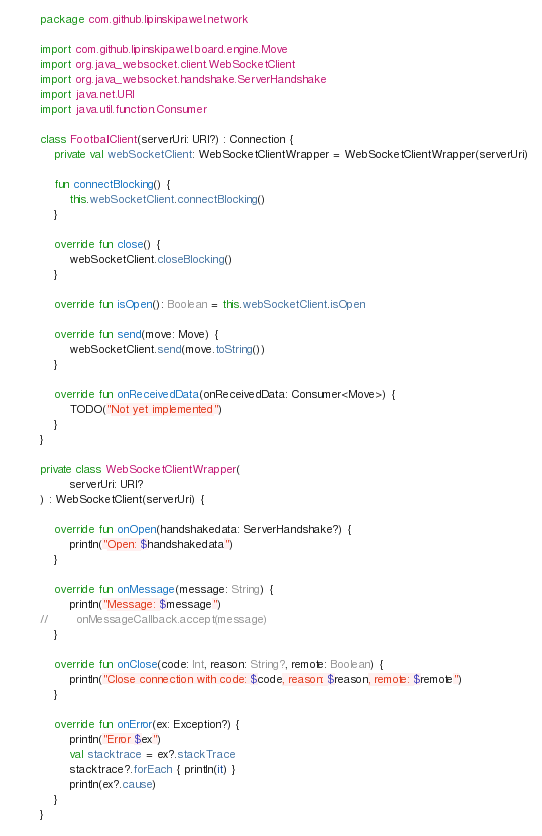<code> <loc_0><loc_0><loc_500><loc_500><_Kotlin_>package com.github.lipinskipawel.network

import com.github.lipinskipawel.board.engine.Move
import org.java_websocket.client.WebSocketClient
import org.java_websocket.handshake.ServerHandshake
import java.net.URI
import java.util.function.Consumer

class FootballClient(serverUri: URI?) : Connection {
    private val webSocketClient: WebSocketClientWrapper = WebSocketClientWrapper(serverUri)

    fun connectBlocking() {
        this.webSocketClient.connectBlocking()
    }

    override fun close() {
        webSocketClient.closeBlocking()
    }

    override fun isOpen(): Boolean = this.webSocketClient.isOpen

    override fun send(move: Move) {
        webSocketClient.send(move.toString())
    }

    override fun onReceivedData(onReceivedData: Consumer<Move>) {
        TODO("Not yet implemented")
    }
}

private class WebSocketClientWrapper(
        serverUri: URI?
) : WebSocketClient(serverUri) {

    override fun onOpen(handshakedata: ServerHandshake?) {
        println("Open: $handshakedata")
    }

    override fun onMessage(message: String) {
        println("Message: $message")
//        onMessageCallback.accept(message)
    }

    override fun onClose(code: Int, reason: String?, remote: Boolean) {
        println("Close connection with code: $code, reason: $reason, remote: $remote")
    }

    override fun onError(ex: Exception?) {
        println("Error $ex")
        val stacktrace = ex?.stackTrace
        stacktrace?.forEach { println(it) }
        println(ex?.cause)
    }
}
</code> 